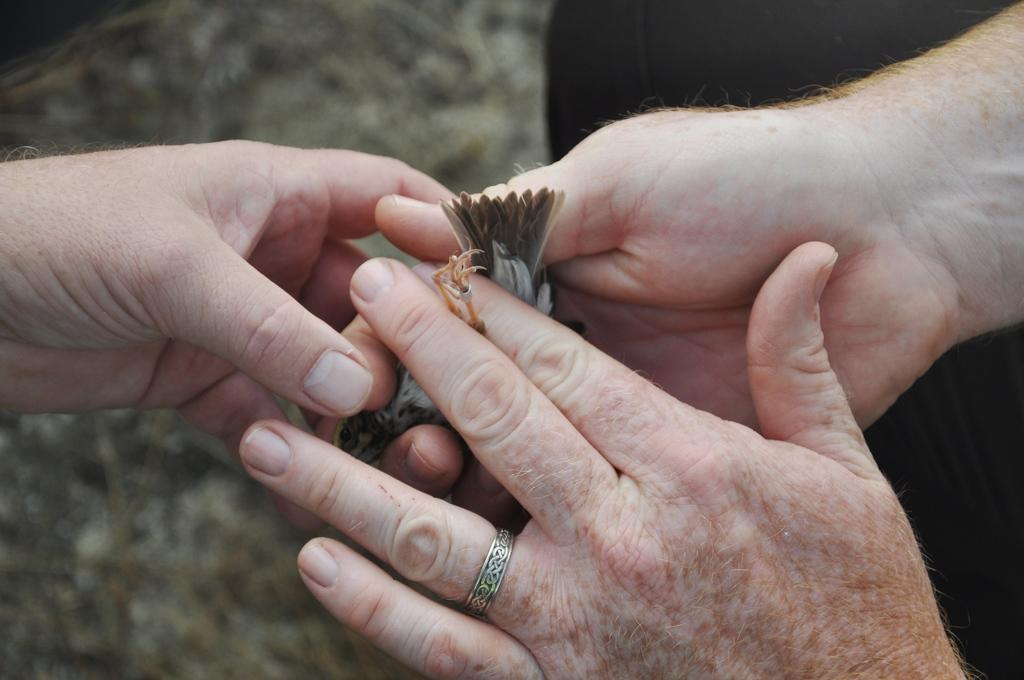What is being held by the hands in the image? There are hands holding a bird in the image. What type of surface is visible at the bottom of the image? There is grass on the surface at the bottom of the image. What type of clouds can be seen in the image? There are no clouds visible in the image; it only shows hands holding a bird and grass at the bottom. 